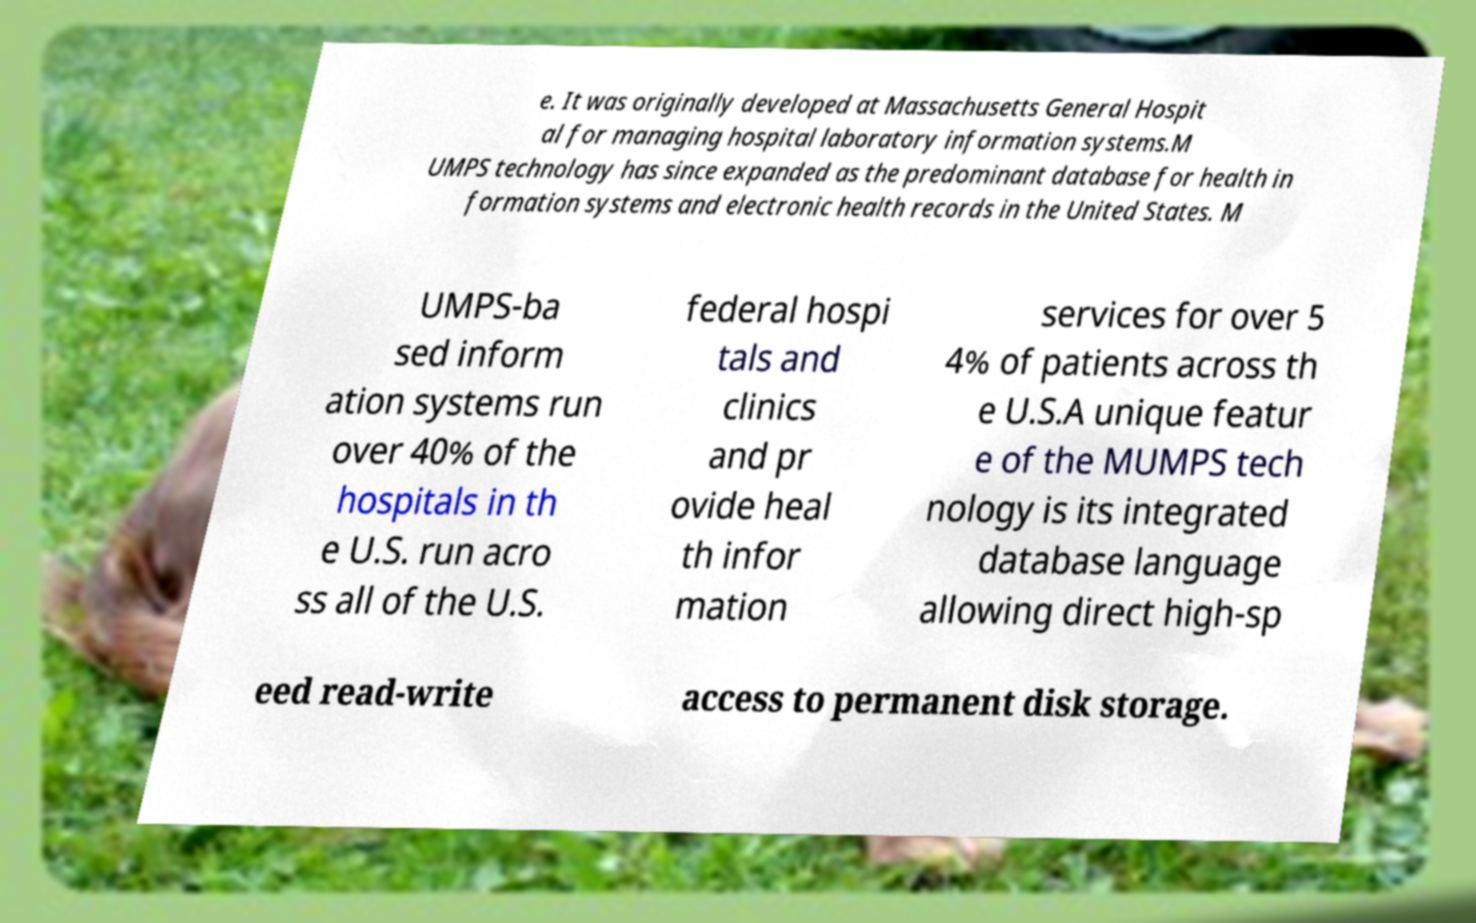Please identify and transcribe the text found in this image. e. It was originally developed at Massachusetts General Hospit al for managing hospital laboratory information systems.M UMPS technology has since expanded as the predominant database for health in formation systems and electronic health records in the United States. M UMPS-ba sed inform ation systems run over 40% of the hospitals in th e U.S. run acro ss all of the U.S. federal hospi tals and clinics and pr ovide heal th infor mation services for over 5 4% of patients across th e U.S.A unique featur e of the MUMPS tech nology is its integrated database language allowing direct high-sp eed read-write access to permanent disk storage. 